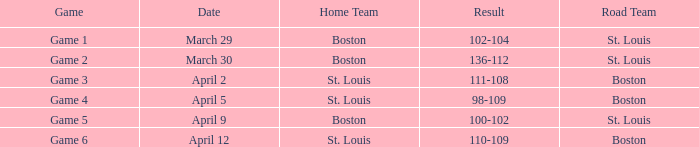What is the upshot of the game on april 9? 100-102. 